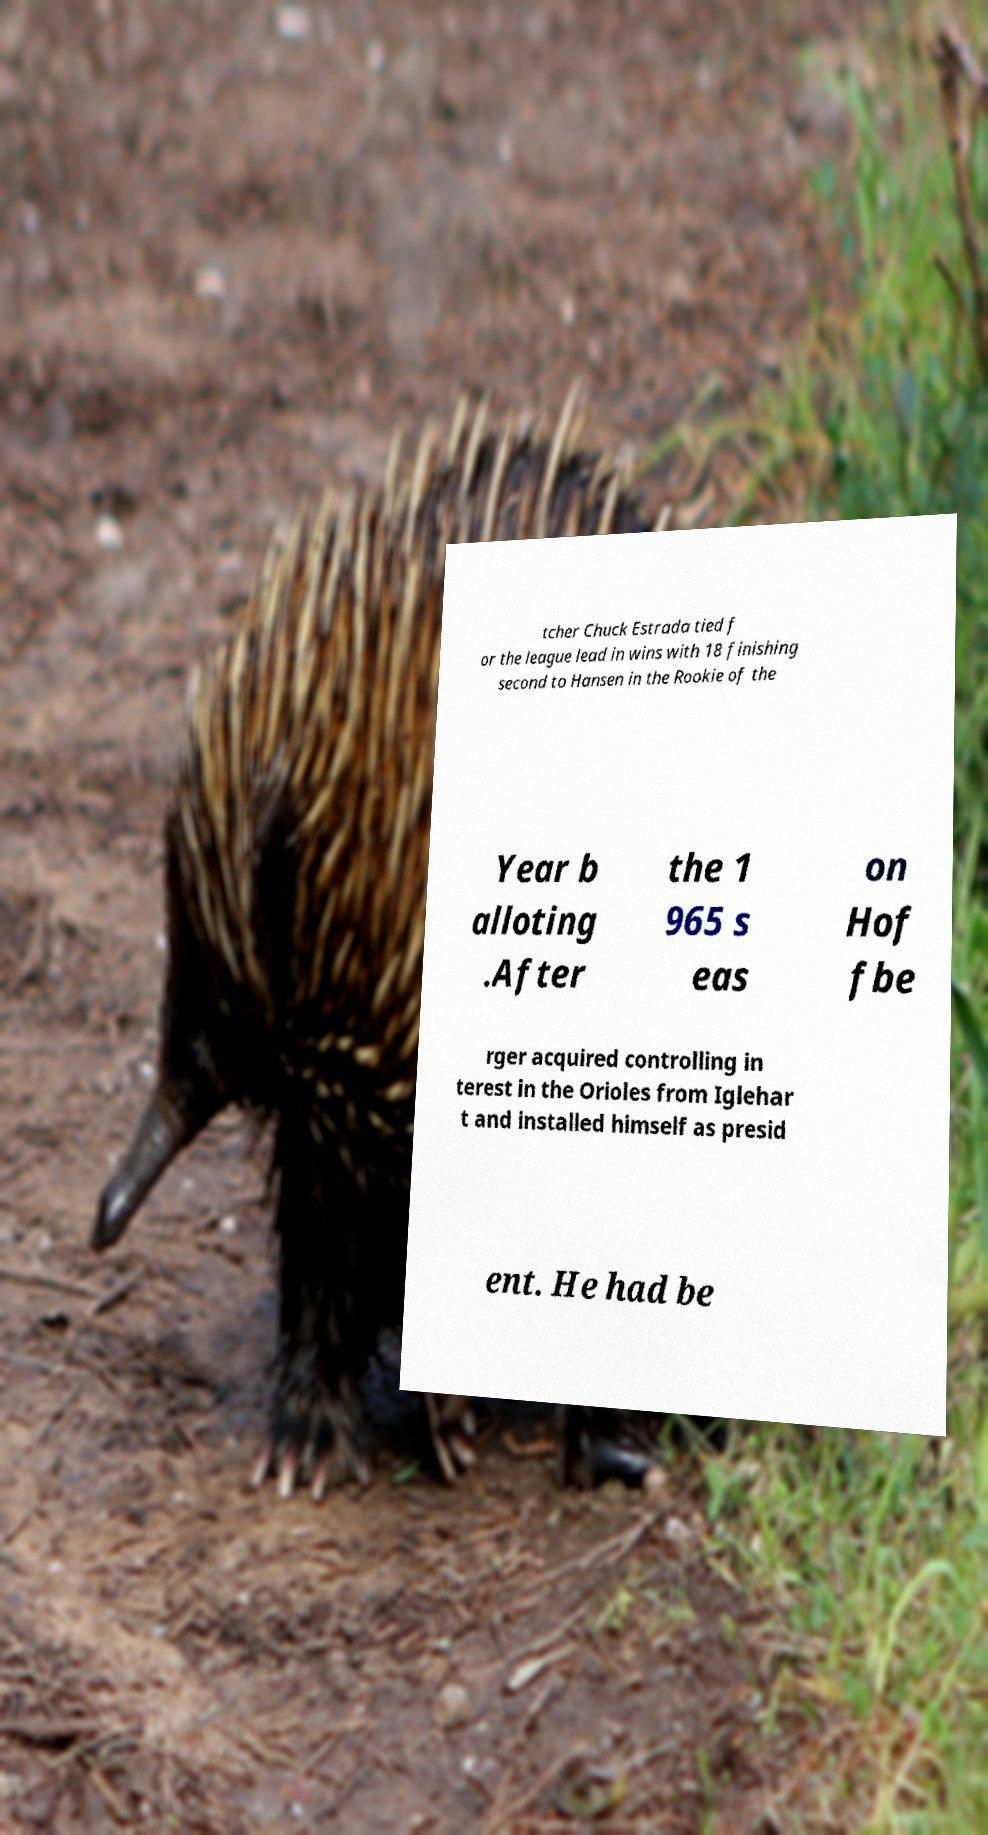Can you read and provide the text displayed in the image?This photo seems to have some interesting text. Can you extract and type it out for me? tcher Chuck Estrada tied f or the league lead in wins with 18 finishing second to Hansen in the Rookie of the Year b alloting .After the 1 965 s eas on Hof fbe rger acquired controlling in terest in the Orioles from Iglehar t and installed himself as presid ent. He had be 